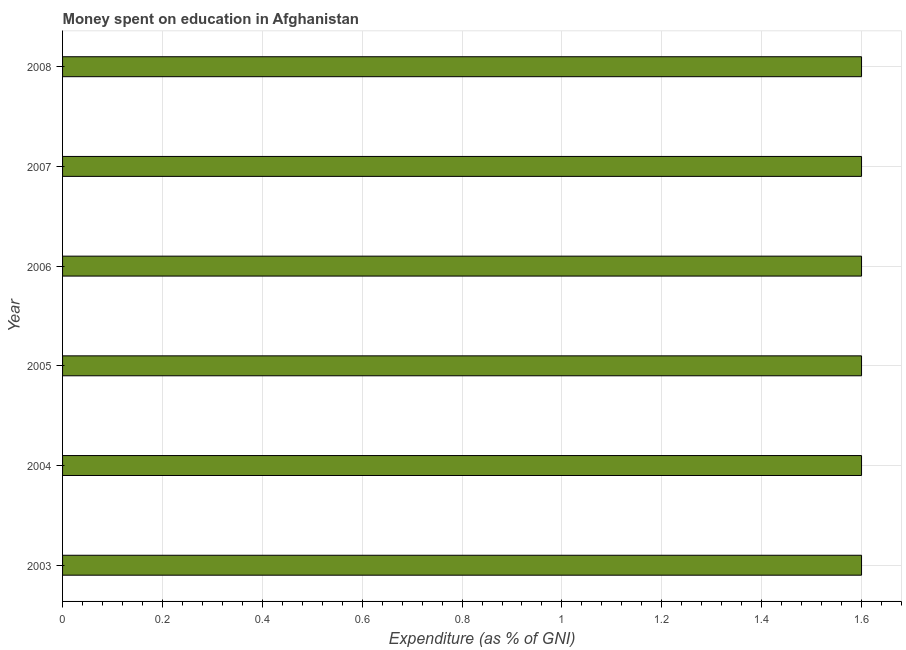Does the graph contain any zero values?
Ensure brevity in your answer.  No. What is the title of the graph?
Ensure brevity in your answer.  Money spent on education in Afghanistan. What is the label or title of the X-axis?
Ensure brevity in your answer.  Expenditure (as % of GNI). What is the label or title of the Y-axis?
Your response must be concise. Year. What is the expenditure on education in 2005?
Your answer should be very brief. 1.6. Across all years, what is the maximum expenditure on education?
Provide a succinct answer. 1.6. Across all years, what is the minimum expenditure on education?
Your answer should be compact. 1.6. In which year was the expenditure on education maximum?
Offer a very short reply. 2003. In which year was the expenditure on education minimum?
Your response must be concise. 2003. What is the average expenditure on education per year?
Keep it short and to the point. 1.6. What is the median expenditure on education?
Keep it short and to the point. 1.6. Is the expenditure on education in 2003 less than that in 2006?
Give a very brief answer. No. What is the difference between the highest and the second highest expenditure on education?
Your response must be concise. 0. What is the difference between the highest and the lowest expenditure on education?
Your response must be concise. 0. How many bars are there?
Provide a short and direct response. 6. Are all the bars in the graph horizontal?
Provide a succinct answer. Yes. How many years are there in the graph?
Ensure brevity in your answer.  6. What is the Expenditure (as % of GNI) in 2003?
Offer a terse response. 1.6. What is the Expenditure (as % of GNI) in 2007?
Keep it short and to the point. 1.6. What is the Expenditure (as % of GNI) of 2008?
Offer a very short reply. 1.6. What is the difference between the Expenditure (as % of GNI) in 2003 and 2005?
Provide a succinct answer. 0. What is the difference between the Expenditure (as % of GNI) in 2004 and 2005?
Provide a short and direct response. 0. What is the difference between the Expenditure (as % of GNI) in 2006 and 2007?
Offer a terse response. 0. What is the ratio of the Expenditure (as % of GNI) in 2003 to that in 2006?
Your answer should be compact. 1. What is the ratio of the Expenditure (as % of GNI) in 2003 to that in 2007?
Give a very brief answer. 1. What is the ratio of the Expenditure (as % of GNI) in 2004 to that in 2006?
Make the answer very short. 1. What is the ratio of the Expenditure (as % of GNI) in 2004 to that in 2007?
Provide a succinct answer. 1. What is the ratio of the Expenditure (as % of GNI) in 2005 to that in 2006?
Keep it short and to the point. 1. What is the ratio of the Expenditure (as % of GNI) in 2005 to that in 2008?
Offer a terse response. 1. What is the ratio of the Expenditure (as % of GNI) in 2006 to that in 2008?
Make the answer very short. 1. What is the ratio of the Expenditure (as % of GNI) in 2007 to that in 2008?
Ensure brevity in your answer.  1. 